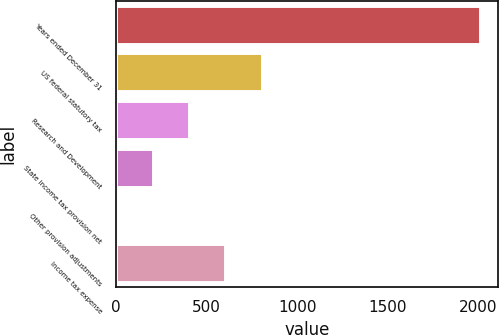Convert chart to OTSL. <chart><loc_0><loc_0><loc_500><loc_500><bar_chart><fcel>Years ended December 31<fcel>US federal statutory tax<fcel>Research and Development<fcel>State income tax provision net<fcel>Other provision adjustments<fcel>Income tax expense<nl><fcel>2008<fcel>803.92<fcel>402.56<fcel>201.88<fcel>1.2<fcel>603.24<nl></chart> 